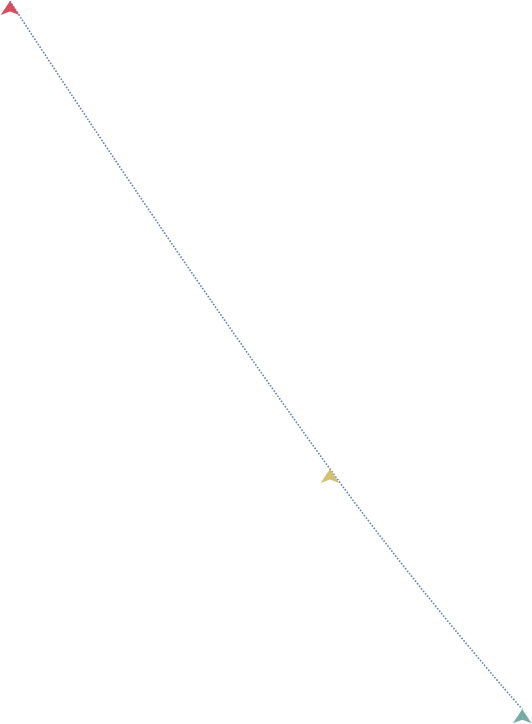Convert chart to OTSL. <chart><loc_0><loc_0><loc_500><loc_500><line_chart><ecel><fcel>Unnamed: 1<nl><fcel>1877.67<fcel>3874.69<nl><fcel>2012.5<fcel>1925.04<nl><fcel>2093.53<fcel>923.93<nl><fcel>2417.04<fcel>515.91<nl></chart> 